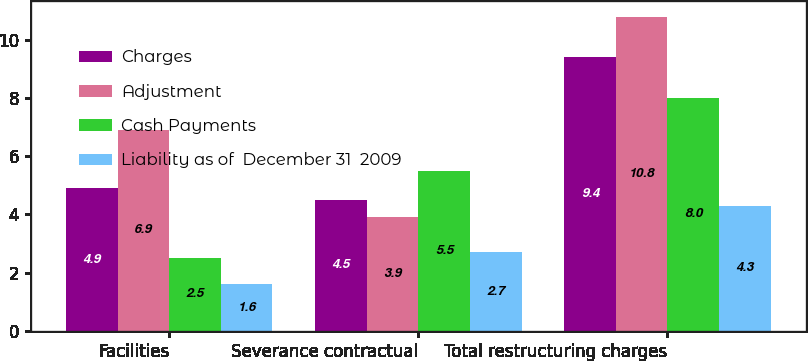<chart> <loc_0><loc_0><loc_500><loc_500><stacked_bar_chart><ecel><fcel>Facilities<fcel>Severance contractual<fcel>Total restructuring charges<nl><fcel>Charges<fcel>4.9<fcel>4.5<fcel>9.4<nl><fcel>Adjustment<fcel>6.9<fcel>3.9<fcel>10.8<nl><fcel>Cash Payments<fcel>2.5<fcel>5.5<fcel>8<nl><fcel>Liability as of  December 31  2009<fcel>1.6<fcel>2.7<fcel>4.3<nl></chart> 